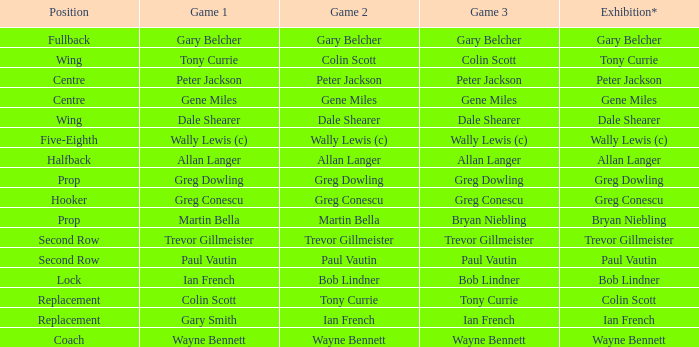Wjat game 3 has ian french as a game of 2? Ian French. 